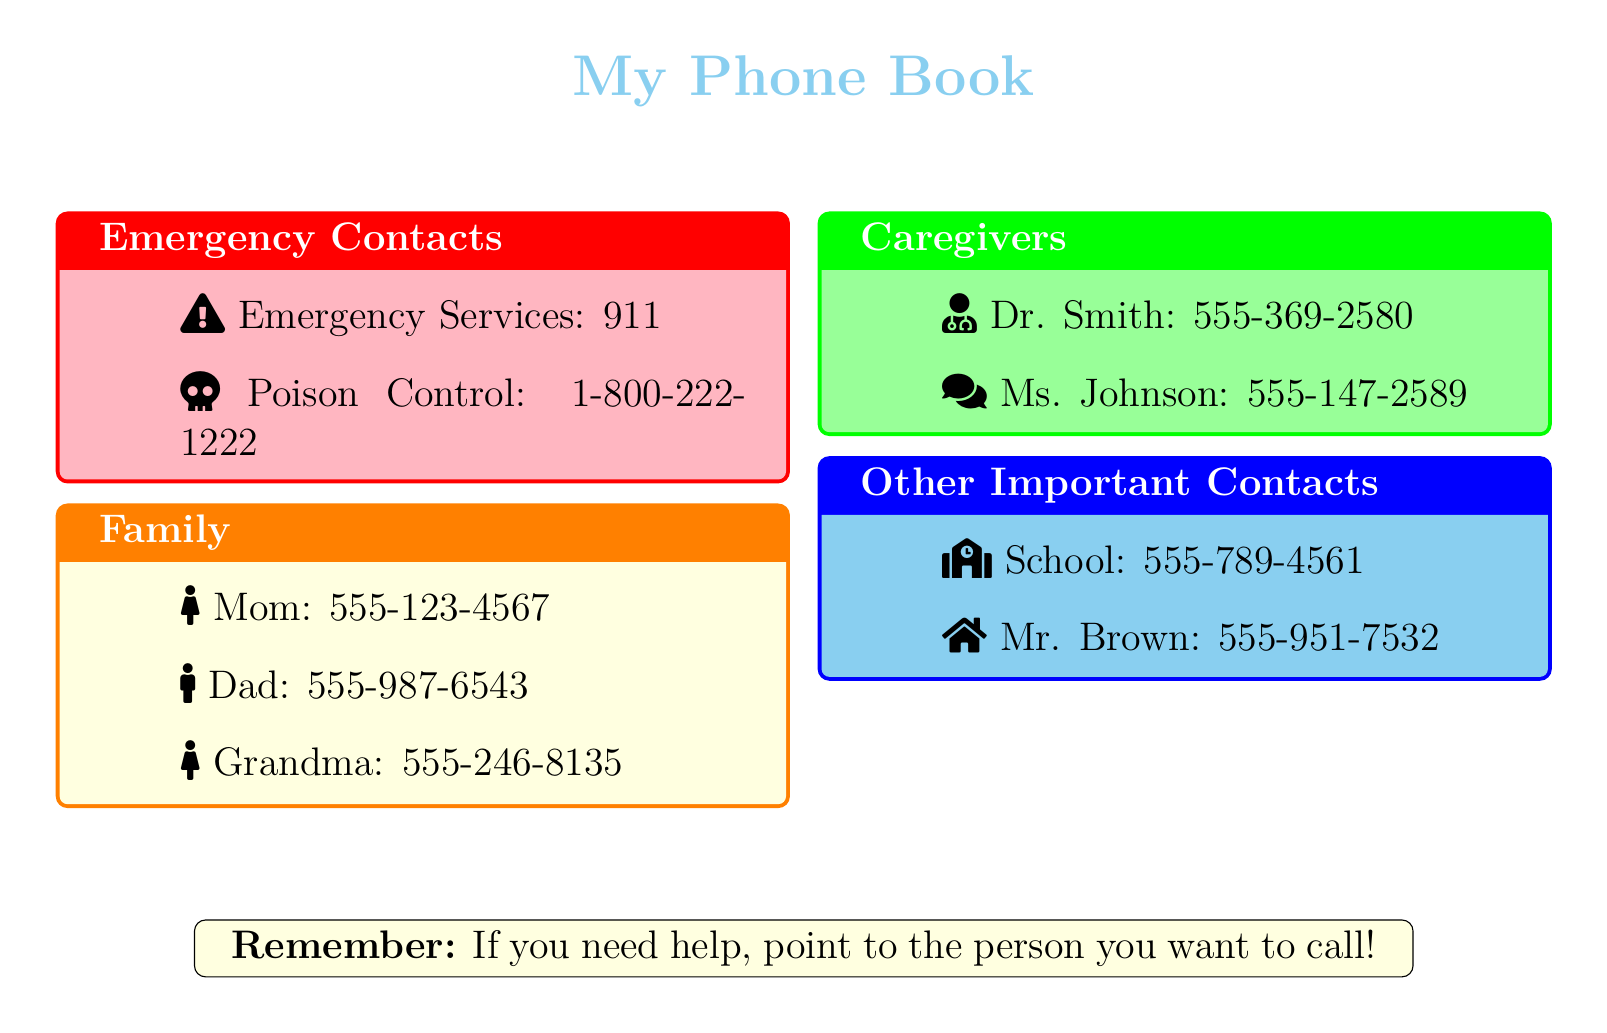What is the phone number for Emergency Services? The phone number for Emergency Services is listed in the Emergency Contacts section of the document as 911.
Answer: 911 Who is listed as Mom in the Family section? The name associated with the contact "Mom" is found in the Family section of the document.
Answer: Mom What is Dr. Smith's phone number? The phone number for Dr. Smith is found in the Caregivers box, which specifies his contact information.
Answer: 555-369-2580 Which icon represents Grandma? The visual aid for Grandma can be identified by looking at the Family section where each person has an icon.
Answer: Female icon How many emergency contacts are listed? The document lists the total number of emergency contacts under the Emergency Contacts section.
Answer: 2 What does the light yellow box represent? The color-coding of the box indicates that it relates to Family, which is the title of that section.
Answer: Family Which caregiver's name is mentioned first? By reviewing the Caregivers section, we can see which name appears first in the list.
Answer: Dr. Smith What contact number is associated with Mr. Brown? The unique number associated with Mr. Brown in the Other Important Contacts section can be found directly in that section of the document.
Answer: 555-951-7532 What is the suggestion in the note at the bottom? The note suggests a way to communicate if help is needed, providing a simple instruction related to calling.
Answer: Point to the person you want to call 